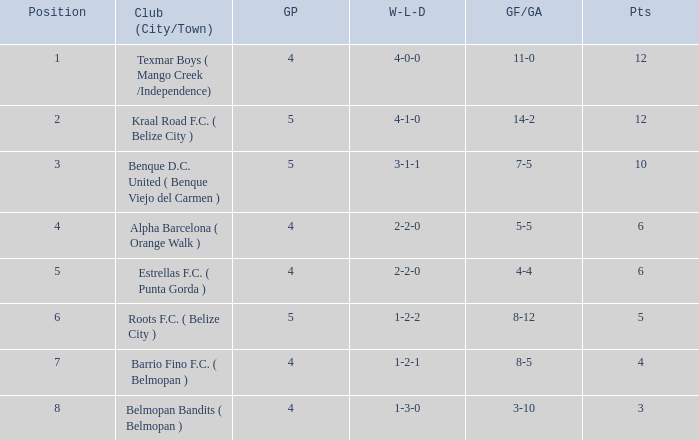What is the minimum games played with goals for/against being 7-5 5.0. 